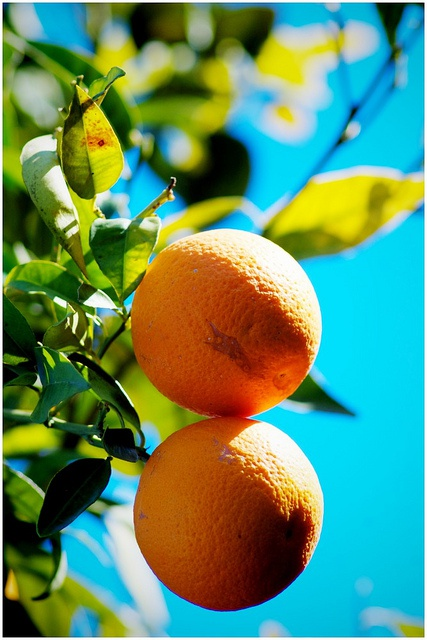Describe the objects in this image and their specific colors. I can see orange in white, maroon, red, and ivory tones and orange in white, red, maroon, and black tones in this image. 